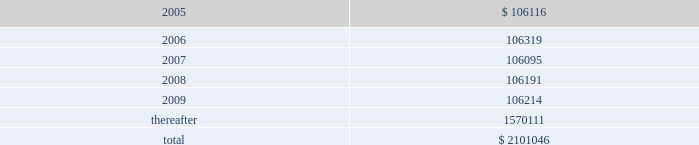American tower corporation and subsidiaries notes to consolidated financial statements 2014 ( continued ) 7 .
Derivative financial instruments under the terms of the credit facility , the company is required to enter into interest rate protection agreements on at least 50% ( 50 % ) of its variable rate debt .
Under these agreements , the company is exposed to credit risk to the extent that a counterparty fails to meet the terms of a contract .
Such exposure is limited to the current value of the contract at the time the counterparty fails to perform .
The company believes its contracts as of december 31 , 2004 are with credit worthy institutions .
As of december 31 , 2004 , the company had two interest rate caps outstanding with an aggregate notional amount of $ 350.0 million ( each at an interest rate of 6.0% ( 6.0 % ) ) that expire in 2006 .
As of december 31 , 2003 , the company had three interest rate caps outstanding with an aggregate notional amount of $ 500.0 million ( each at a rate of 5.0% ( 5.0 % ) ) that expired in 2004 .
As of december 31 , 2004 and 2003 , there was no fair value associated with any of these interest rate caps .
During the year ended december 31 , 2003 , the company recorded an unrealized loss of approximately $ 0.3 million ( net of a tax benefit of approximately $ 0.2 million ) in other comprehensive loss for the change in fair value of cash flow hedges and reclassified $ 5.9 million ( net of a tax benefit of approximately $ 3.2 million ) into results of operations .
During the year ended december 31 , 2002 , the company recorded an unrealized loss of approximately $ 9.1 million ( net of a tax benefit of approximately $ 4.9 million ) in other comprehensive loss for the change in fair value of cash flow hedges and reclassified $ 19.5 million ( net of a tax benefit of approximately $ 10.5 million ) into results of operations .
Hedge ineffectiveness resulted in a gain of approximately $ 1.0 million for the year ended december 31 , 2002 , which is recorded in other expense in the accompanying consolidated statement of operations .
The company records the changes in fair value of its derivative instruments that are not accounted for as hedges in other expense .
The company did not reclassify any derivative losses into its statement of operations for the year ended december 31 , 2004 and does not anticipate reclassifying any derivative losses into its statement of operations within the next twelve months , as there are no amounts included in other comprehensive loss as of december 31 , 2004 .
Commitments and contingencies lease obligations 2014the company leases certain land , office and tower space under operating leases that expire over various terms .
Many of the leases contain renewal options with specified increases in lease payments upon exercise of the renewal option .
Escalation clauses present in operating leases , excluding those tied to cpi or other inflation-based indices , are straight-lined over the term of the lease .
( see note 1. ) future minimum rental payments under non-cancelable operating leases include payments for certain renewal periods at the company 2019s option because failure to renew could result in a loss of the applicable tower site and related revenues from tenant leases , thereby making it reasonably assured that the company will renew the lease .
Such payments in effect at december 31 , 2004 are as follows ( in thousands ) : year ending december 31 .
Aggregate rent expense ( including the effect of straight-line rent expense ) under operating leases for the years ended december 31 , 2004 , 2003 and 2002 approximated $ 118741000 , $ 113956000 , and $ 109644000 , respectively. .
What was the average rental expense between 2002 and 2004? 
Computations: (((118741000 + 113956000) + 109644000) / 3)
Answer: 114113666.66667. 